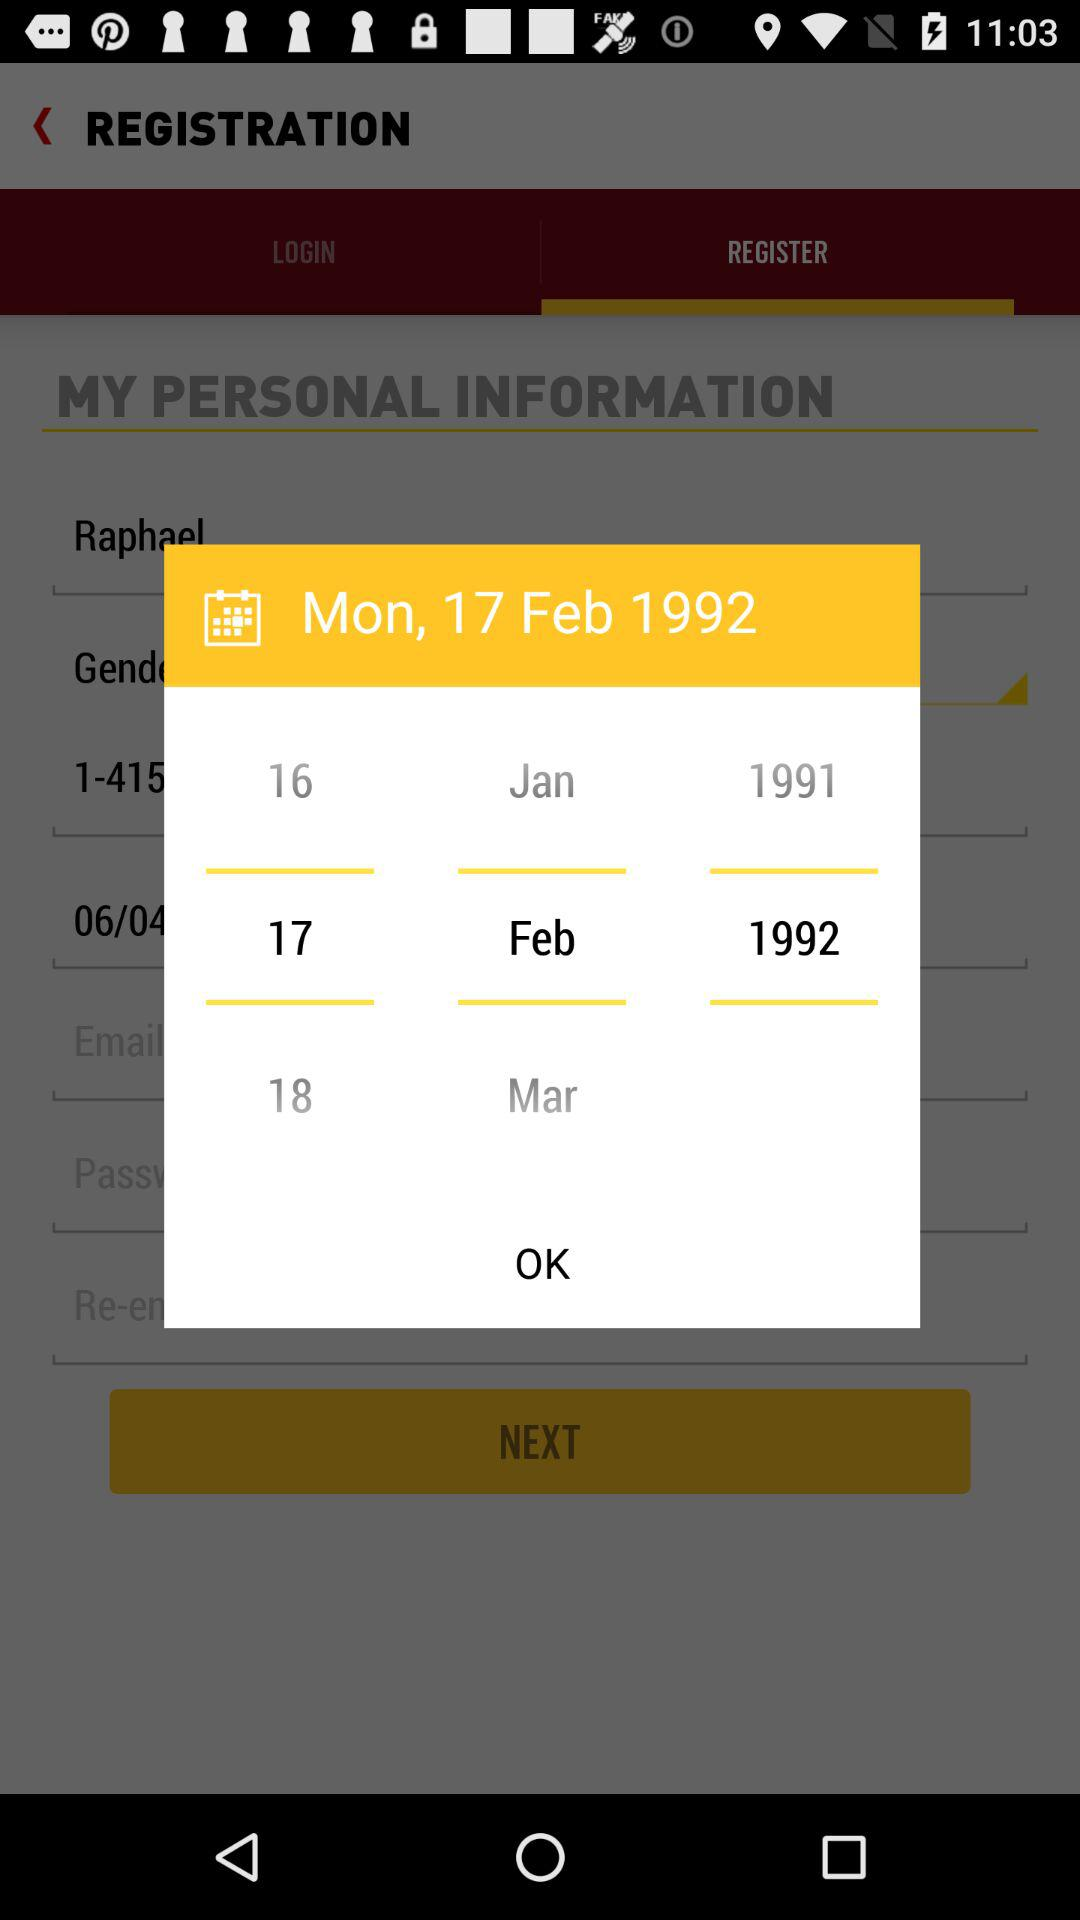What day is it on the chosen date? The day is Monday. 